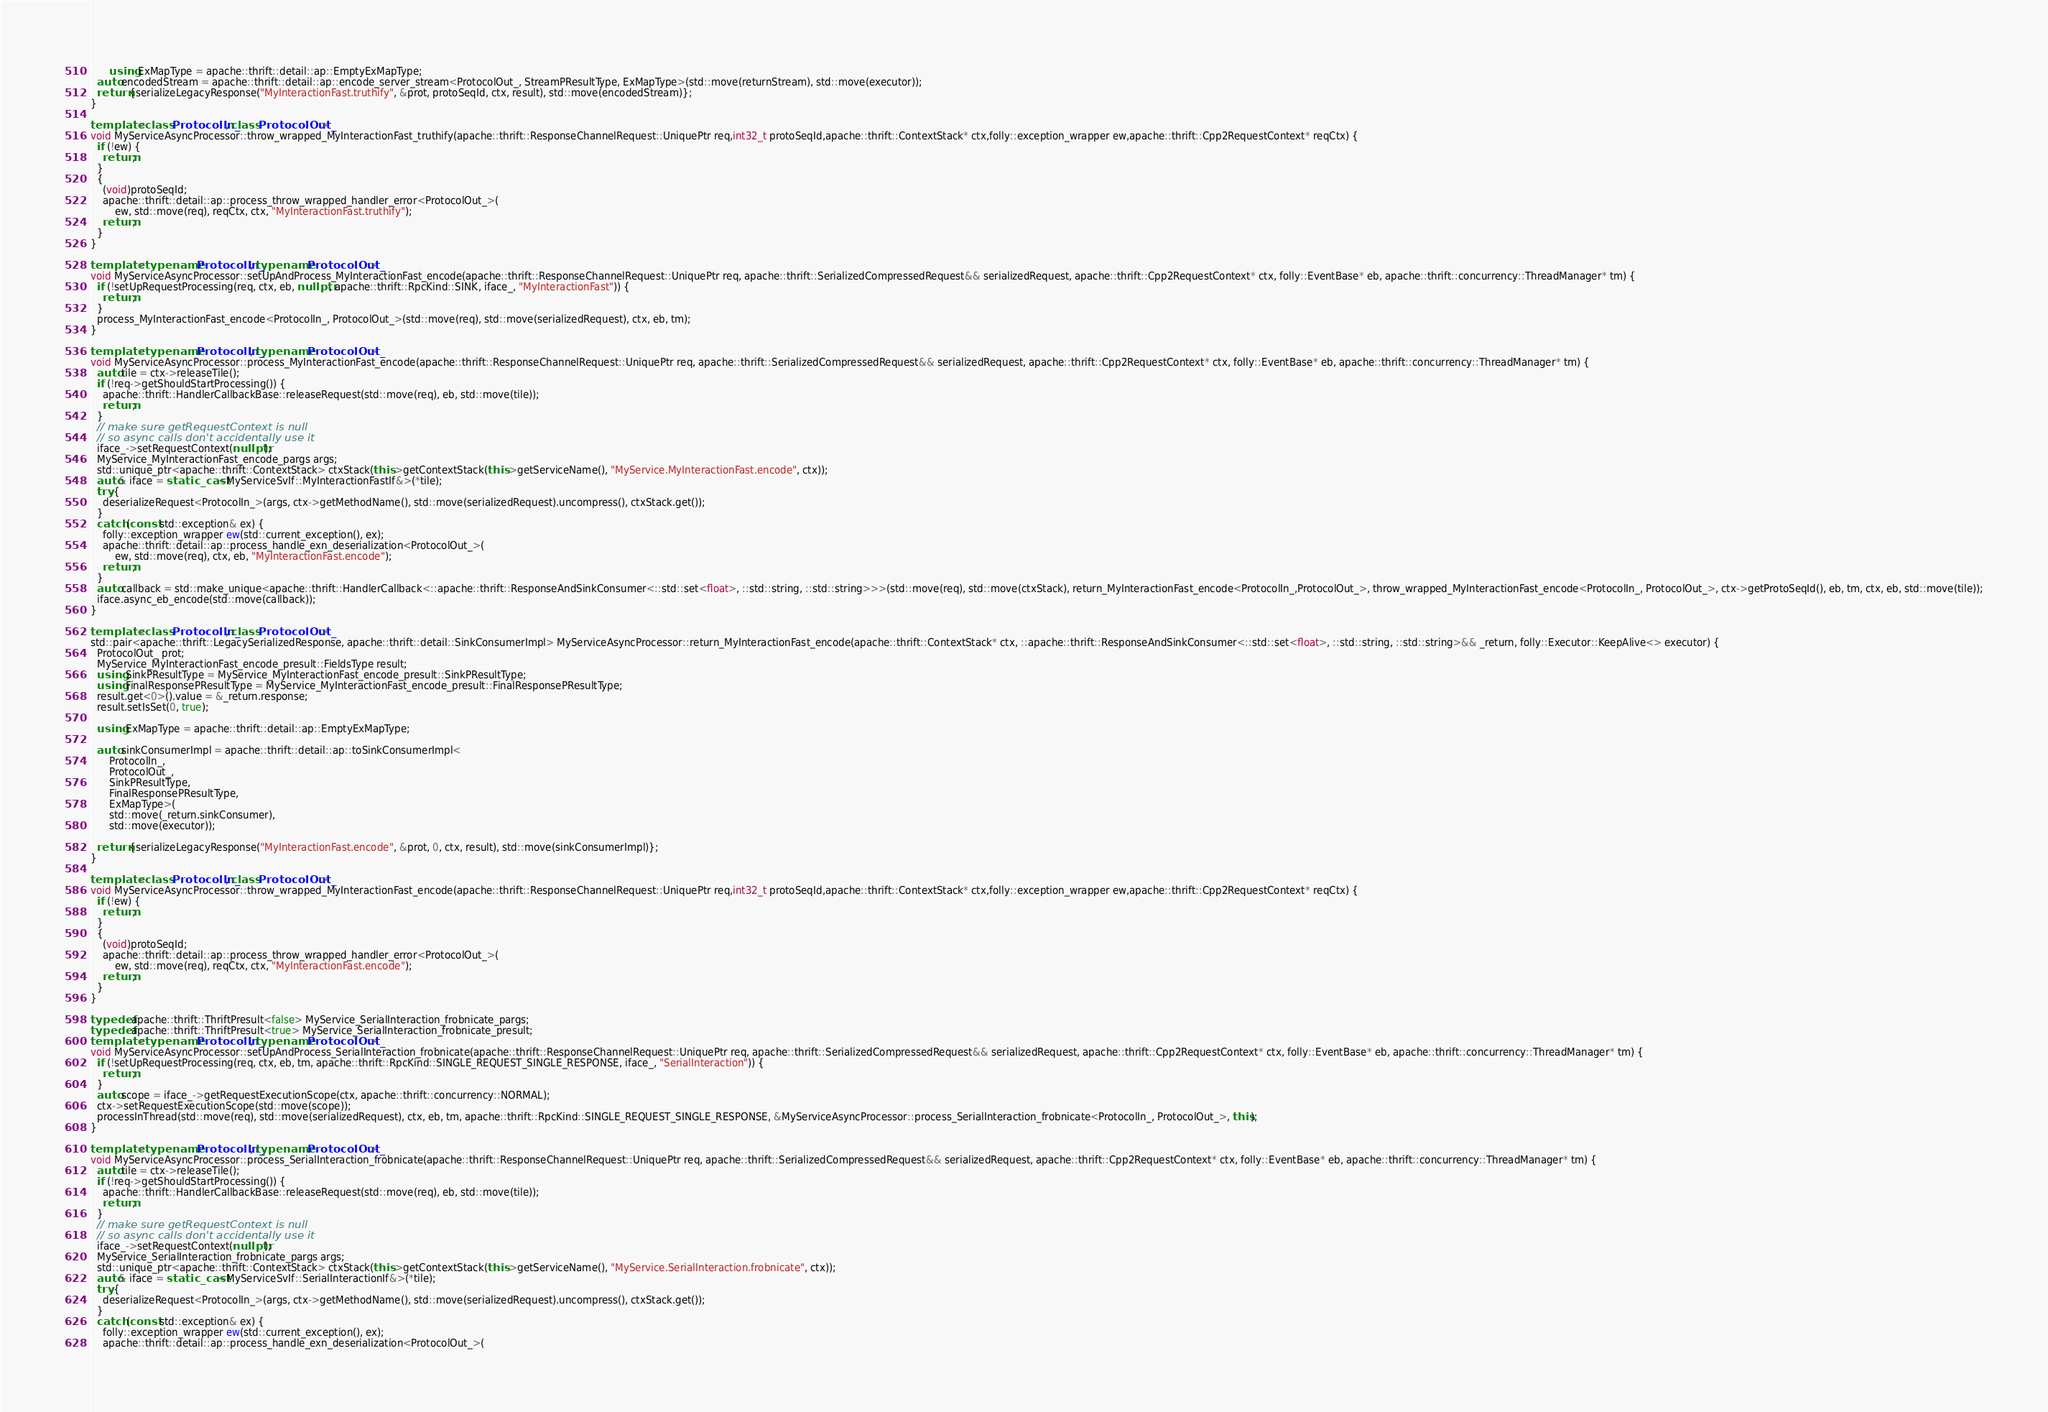Convert code to text. <code><loc_0><loc_0><loc_500><loc_500><_C++_>
      using ExMapType = apache::thrift::detail::ap::EmptyExMapType;
  auto encodedStream = apache::thrift::detail::ap::encode_server_stream<ProtocolOut_, StreamPResultType, ExMapType>(std::move(returnStream), std::move(executor));
  return {serializeLegacyResponse("MyInteractionFast.truthify", &prot, protoSeqId, ctx, result), std::move(encodedStream)};
}

template <class ProtocolIn_, class ProtocolOut_>
void MyServiceAsyncProcessor::throw_wrapped_MyInteractionFast_truthify(apache::thrift::ResponseChannelRequest::UniquePtr req,int32_t protoSeqId,apache::thrift::ContextStack* ctx,folly::exception_wrapper ew,apache::thrift::Cpp2RequestContext* reqCtx) {
  if (!ew) {
    return;
  }
  {
    (void)protoSeqId;
    apache::thrift::detail::ap::process_throw_wrapped_handler_error<ProtocolOut_>(
        ew, std::move(req), reqCtx, ctx, "MyInteractionFast.truthify");
    return;
  }
}

template <typename ProtocolIn_, typename ProtocolOut_>
void MyServiceAsyncProcessor::setUpAndProcess_MyInteractionFast_encode(apache::thrift::ResponseChannelRequest::UniquePtr req, apache::thrift::SerializedCompressedRequest&& serializedRequest, apache::thrift::Cpp2RequestContext* ctx, folly::EventBase* eb, apache::thrift::concurrency::ThreadManager* tm) {
  if (!setUpRequestProcessing(req, ctx, eb, nullptr, apache::thrift::RpcKind::SINK, iface_, "MyInteractionFast")) {
    return;
  }
  process_MyInteractionFast_encode<ProtocolIn_, ProtocolOut_>(std::move(req), std::move(serializedRequest), ctx, eb, tm);
}

template <typename ProtocolIn_, typename ProtocolOut_>
void MyServiceAsyncProcessor::process_MyInteractionFast_encode(apache::thrift::ResponseChannelRequest::UniquePtr req, apache::thrift::SerializedCompressedRequest&& serializedRequest, apache::thrift::Cpp2RequestContext* ctx, folly::EventBase* eb, apache::thrift::concurrency::ThreadManager* tm) {
  auto tile = ctx->releaseTile();
  if (!req->getShouldStartProcessing()) {
    apache::thrift::HandlerCallbackBase::releaseRequest(std::move(req), eb, std::move(tile));
    return;
  }
  // make sure getRequestContext is null
  // so async calls don't accidentally use it
  iface_->setRequestContext(nullptr);
  MyService_MyInteractionFast_encode_pargs args;
  std::unique_ptr<apache::thrift::ContextStack> ctxStack(this->getContextStack(this->getServiceName(), "MyService.MyInteractionFast.encode", ctx));
  auto& iface = static_cast<MyServiceSvIf::MyInteractionFastIf&>(*tile);
  try {
    deserializeRequest<ProtocolIn_>(args, ctx->getMethodName(), std::move(serializedRequest).uncompress(), ctxStack.get());
  }
  catch (const std::exception& ex) {
    folly::exception_wrapper ew(std::current_exception(), ex);
    apache::thrift::detail::ap::process_handle_exn_deserialization<ProtocolOut_>(
        ew, std::move(req), ctx, eb, "MyInteractionFast.encode");
    return;
  }
  auto callback = std::make_unique<apache::thrift::HandlerCallback<::apache::thrift::ResponseAndSinkConsumer<::std::set<float>, ::std::string, ::std::string>>>(std::move(req), std::move(ctxStack), return_MyInteractionFast_encode<ProtocolIn_,ProtocolOut_>, throw_wrapped_MyInteractionFast_encode<ProtocolIn_, ProtocolOut_>, ctx->getProtoSeqId(), eb, tm, ctx, eb, std::move(tile));
  iface.async_eb_encode(std::move(callback));
}

template <class ProtocolIn_, class ProtocolOut_>
std::pair<apache::thrift::LegacySerializedResponse, apache::thrift::detail::SinkConsumerImpl> MyServiceAsyncProcessor::return_MyInteractionFast_encode(apache::thrift::ContextStack* ctx, ::apache::thrift::ResponseAndSinkConsumer<::std::set<float>, ::std::string, ::std::string>&& _return, folly::Executor::KeepAlive<> executor) {
  ProtocolOut_ prot;
  MyService_MyInteractionFast_encode_presult::FieldsType result;
  using SinkPResultType = MyService_MyInteractionFast_encode_presult::SinkPResultType;
  using FinalResponsePResultType = MyService_MyInteractionFast_encode_presult::FinalResponsePResultType;
  result.get<0>().value = &_return.response;
  result.setIsSet(0, true);

  using ExMapType = apache::thrift::detail::ap::EmptyExMapType;

  auto sinkConsumerImpl = apache::thrift::detail::ap::toSinkConsumerImpl<
      ProtocolIn_,
      ProtocolOut_,
      SinkPResultType,
      FinalResponsePResultType,
      ExMapType>(
      std::move(_return.sinkConsumer),
      std::move(executor));

  return {serializeLegacyResponse("MyInteractionFast.encode", &prot, 0, ctx, result), std::move(sinkConsumerImpl)};
}

template <class ProtocolIn_, class ProtocolOut_>
void MyServiceAsyncProcessor::throw_wrapped_MyInteractionFast_encode(apache::thrift::ResponseChannelRequest::UniquePtr req,int32_t protoSeqId,apache::thrift::ContextStack* ctx,folly::exception_wrapper ew,apache::thrift::Cpp2RequestContext* reqCtx) {
  if (!ew) {
    return;
  }
  {
    (void)protoSeqId;
    apache::thrift::detail::ap::process_throw_wrapped_handler_error<ProtocolOut_>(
        ew, std::move(req), reqCtx, ctx, "MyInteractionFast.encode");
    return;
  }
}

typedef apache::thrift::ThriftPresult<false> MyService_SerialInteraction_frobnicate_pargs;
typedef apache::thrift::ThriftPresult<true> MyService_SerialInteraction_frobnicate_presult;
template <typename ProtocolIn_, typename ProtocolOut_>
void MyServiceAsyncProcessor::setUpAndProcess_SerialInteraction_frobnicate(apache::thrift::ResponseChannelRequest::UniquePtr req, apache::thrift::SerializedCompressedRequest&& serializedRequest, apache::thrift::Cpp2RequestContext* ctx, folly::EventBase* eb, apache::thrift::concurrency::ThreadManager* tm) {
  if (!setUpRequestProcessing(req, ctx, eb, tm, apache::thrift::RpcKind::SINGLE_REQUEST_SINGLE_RESPONSE, iface_, "SerialInteraction")) {
    return;
  }
  auto scope = iface_->getRequestExecutionScope(ctx, apache::thrift::concurrency::NORMAL);
  ctx->setRequestExecutionScope(std::move(scope));
  processInThread(std::move(req), std::move(serializedRequest), ctx, eb, tm, apache::thrift::RpcKind::SINGLE_REQUEST_SINGLE_RESPONSE, &MyServiceAsyncProcessor::process_SerialInteraction_frobnicate<ProtocolIn_, ProtocolOut_>, this);
}

template <typename ProtocolIn_, typename ProtocolOut_>
void MyServiceAsyncProcessor::process_SerialInteraction_frobnicate(apache::thrift::ResponseChannelRequest::UniquePtr req, apache::thrift::SerializedCompressedRequest&& serializedRequest, apache::thrift::Cpp2RequestContext* ctx, folly::EventBase* eb, apache::thrift::concurrency::ThreadManager* tm) {
  auto tile = ctx->releaseTile();
  if (!req->getShouldStartProcessing()) {
    apache::thrift::HandlerCallbackBase::releaseRequest(std::move(req), eb, std::move(tile));
    return;
  }
  // make sure getRequestContext is null
  // so async calls don't accidentally use it
  iface_->setRequestContext(nullptr);
  MyService_SerialInteraction_frobnicate_pargs args;
  std::unique_ptr<apache::thrift::ContextStack> ctxStack(this->getContextStack(this->getServiceName(), "MyService.SerialInteraction.frobnicate", ctx));
  auto& iface = static_cast<MyServiceSvIf::SerialInteractionIf&>(*tile);
  try {
    deserializeRequest<ProtocolIn_>(args, ctx->getMethodName(), std::move(serializedRequest).uncompress(), ctxStack.get());
  }
  catch (const std::exception& ex) {
    folly::exception_wrapper ew(std::current_exception(), ex);
    apache::thrift::detail::ap::process_handle_exn_deserialization<ProtocolOut_>(</code> 